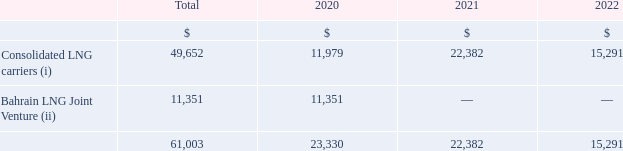A) vessels under construction and upgrades
teekay lng's share of commitments to fund newbuilding and other construction contract costs as at december 31, 2019 are as follows:
(i) in june 2019, teekay lng entered into an agreement with a contractor to supply equipment on certain of its lng carriers in 2021 and 2022, for an estimated installed cost of approximately $60.6 million. as at december 31, 2019, the estimated remaining cost of this installation is $49.7 million.
(ii) teekay lng has a 30% ownership interest in the bahrain lng joint venture which has an lng receiving and regasification terminal in bahrain. the bahrain lng joint venture has secured undrawn debt financing of $34 million, of which $10 million relates to teekay lng's proportionate share of the commitments included in the table above.
what agreement did teekay lng entered in june 2019? In june 2019, teekay lng entered into an agreement with a contractor to supply equipment on certain of its lng carriers in 2021 and 2022. What was the estimated installed cost of Teenkay LNG's agreement with a contractor? Estimated installed cost of approximately $60.6 million. What as the remaining cost of installation as at December 31, 2019? As at december 31, 2019, the estimated remaining cost of this installation is $49.7 million. What is the increase/ (decrease) in Consolidated LNG carriers from 2020 to 2021?
Answer scale should be: million. 22,382-11,979
Answer: 10403. What is the increase/ (decrease) in Consolidated LNG carriers from 2021 to 2022?
Answer scale should be: million. 15,291-22,382
Answer: -7091. What is the average Consolidated LNG carriers, for the year 2020 to 2021?
Answer scale should be: million. (22,382+11,979) / 2
Answer: 17180.5. 